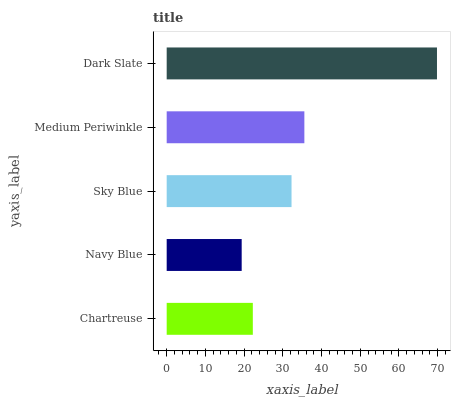Is Navy Blue the minimum?
Answer yes or no. Yes. Is Dark Slate the maximum?
Answer yes or no. Yes. Is Sky Blue the minimum?
Answer yes or no. No. Is Sky Blue the maximum?
Answer yes or no. No. Is Sky Blue greater than Navy Blue?
Answer yes or no. Yes. Is Navy Blue less than Sky Blue?
Answer yes or no. Yes. Is Navy Blue greater than Sky Blue?
Answer yes or no. No. Is Sky Blue less than Navy Blue?
Answer yes or no. No. Is Sky Blue the high median?
Answer yes or no. Yes. Is Sky Blue the low median?
Answer yes or no. Yes. Is Navy Blue the high median?
Answer yes or no. No. Is Navy Blue the low median?
Answer yes or no. No. 